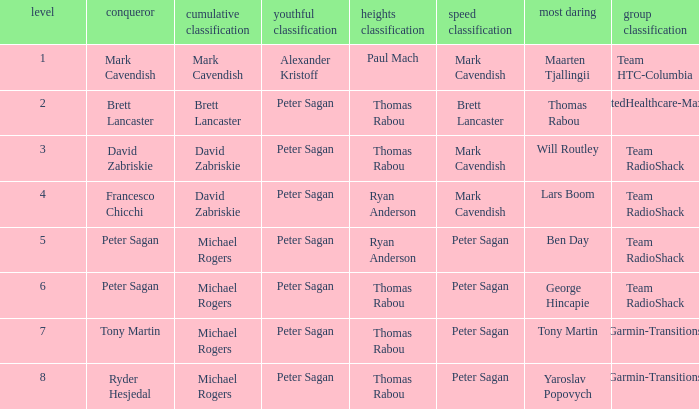When Yaroslav Popovych won most corageous, who won the mountains classification? Thomas Rabou. 